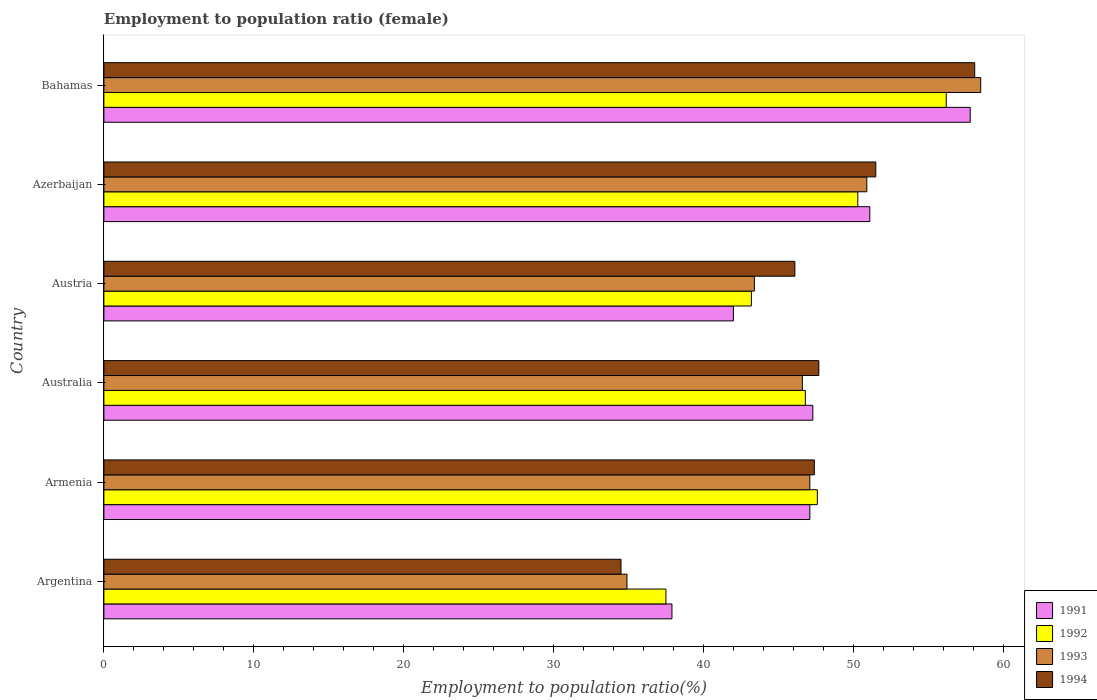How many different coloured bars are there?
Your answer should be very brief. 4. How many groups of bars are there?
Give a very brief answer. 6. Are the number of bars per tick equal to the number of legend labels?
Provide a short and direct response. Yes. Are the number of bars on each tick of the Y-axis equal?
Your response must be concise. Yes. How many bars are there on the 6th tick from the bottom?
Your answer should be very brief. 4. In how many cases, is the number of bars for a given country not equal to the number of legend labels?
Offer a very short reply. 0. What is the employment to population ratio in 1992 in Australia?
Your answer should be very brief. 46.8. Across all countries, what is the maximum employment to population ratio in 1991?
Your answer should be compact. 57.8. Across all countries, what is the minimum employment to population ratio in 1991?
Your answer should be very brief. 37.9. In which country was the employment to population ratio in 1993 maximum?
Your answer should be compact. Bahamas. In which country was the employment to population ratio in 1993 minimum?
Offer a very short reply. Argentina. What is the total employment to population ratio in 1994 in the graph?
Offer a very short reply. 285.3. What is the difference between the employment to population ratio in 1994 in Argentina and that in Armenia?
Make the answer very short. -12.9. What is the difference between the employment to population ratio in 1994 in Argentina and the employment to population ratio in 1993 in Armenia?
Offer a very short reply. -12.6. What is the average employment to population ratio in 1991 per country?
Make the answer very short. 47.2. What is the difference between the employment to population ratio in 1993 and employment to population ratio in 1991 in Austria?
Make the answer very short. 1.4. In how many countries, is the employment to population ratio in 1991 greater than 50 %?
Provide a succinct answer. 2. What is the ratio of the employment to population ratio in 1994 in Argentina to that in Azerbaijan?
Provide a succinct answer. 0.67. Is the employment to population ratio in 1991 in Argentina less than that in Bahamas?
Your answer should be very brief. Yes. Is the difference between the employment to population ratio in 1993 in Australia and Azerbaijan greater than the difference between the employment to population ratio in 1991 in Australia and Azerbaijan?
Your answer should be very brief. No. What is the difference between the highest and the second highest employment to population ratio in 1991?
Make the answer very short. 6.7. What is the difference between the highest and the lowest employment to population ratio in 1994?
Your response must be concise. 23.6. In how many countries, is the employment to population ratio in 1991 greater than the average employment to population ratio in 1991 taken over all countries?
Keep it short and to the point. 3. Is the sum of the employment to population ratio in 1993 in Azerbaijan and Bahamas greater than the maximum employment to population ratio in 1991 across all countries?
Offer a very short reply. Yes. Is it the case that in every country, the sum of the employment to population ratio in 1991 and employment to population ratio in 1993 is greater than the sum of employment to population ratio in 1994 and employment to population ratio in 1992?
Make the answer very short. No. Is it the case that in every country, the sum of the employment to population ratio in 1992 and employment to population ratio in 1991 is greater than the employment to population ratio in 1993?
Give a very brief answer. Yes. Are all the bars in the graph horizontal?
Offer a terse response. Yes. What is the difference between two consecutive major ticks on the X-axis?
Ensure brevity in your answer.  10. Does the graph contain any zero values?
Offer a terse response. No. Does the graph contain grids?
Make the answer very short. No. What is the title of the graph?
Offer a terse response. Employment to population ratio (female). What is the label or title of the Y-axis?
Keep it short and to the point. Country. What is the Employment to population ratio(%) in 1991 in Argentina?
Make the answer very short. 37.9. What is the Employment to population ratio(%) of 1992 in Argentina?
Your answer should be compact. 37.5. What is the Employment to population ratio(%) of 1993 in Argentina?
Make the answer very short. 34.9. What is the Employment to population ratio(%) in 1994 in Argentina?
Provide a short and direct response. 34.5. What is the Employment to population ratio(%) of 1991 in Armenia?
Your response must be concise. 47.1. What is the Employment to population ratio(%) of 1992 in Armenia?
Your answer should be very brief. 47.6. What is the Employment to population ratio(%) of 1993 in Armenia?
Offer a terse response. 47.1. What is the Employment to population ratio(%) in 1994 in Armenia?
Make the answer very short. 47.4. What is the Employment to population ratio(%) in 1991 in Australia?
Ensure brevity in your answer.  47.3. What is the Employment to population ratio(%) in 1992 in Australia?
Make the answer very short. 46.8. What is the Employment to population ratio(%) of 1993 in Australia?
Your answer should be very brief. 46.6. What is the Employment to population ratio(%) of 1994 in Australia?
Your answer should be compact. 47.7. What is the Employment to population ratio(%) of 1992 in Austria?
Your answer should be very brief. 43.2. What is the Employment to population ratio(%) of 1993 in Austria?
Your answer should be compact. 43.4. What is the Employment to population ratio(%) of 1994 in Austria?
Keep it short and to the point. 46.1. What is the Employment to population ratio(%) in 1991 in Azerbaijan?
Provide a succinct answer. 51.1. What is the Employment to population ratio(%) of 1992 in Azerbaijan?
Give a very brief answer. 50.3. What is the Employment to population ratio(%) in 1993 in Azerbaijan?
Ensure brevity in your answer.  50.9. What is the Employment to population ratio(%) in 1994 in Azerbaijan?
Make the answer very short. 51.5. What is the Employment to population ratio(%) in 1991 in Bahamas?
Offer a terse response. 57.8. What is the Employment to population ratio(%) in 1992 in Bahamas?
Your answer should be compact. 56.2. What is the Employment to population ratio(%) in 1993 in Bahamas?
Give a very brief answer. 58.5. What is the Employment to population ratio(%) in 1994 in Bahamas?
Your answer should be very brief. 58.1. Across all countries, what is the maximum Employment to population ratio(%) in 1991?
Your answer should be very brief. 57.8. Across all countries, what is the maximum Employment to population ratio(%) in 1992?
Provide a short and direct response. 56.2. Across all countries, what is the maximum Employment to population ratio(%) in 1993?
Provide a short and direct response. 58.5. Across all countries, what is the maximum Employment to population ratio(%) of 1994?
Give a very brief answer. 58.1. Across all countries, what is the minimum Employment to population ratio(%) in 1991?
Offer a terse response. 37.9. Across all countries, what is the minimum Employment to population ratio(%) in 1992?
Provide a succinct answer. 37.5. Across all countries, what is the minimum Employment to population ratio(%) of 1993?
Provide a short and direct response. 34.9. Across all countries, what is the minimum Employment to population ratio(%) in 1994?
Offer a terse response. 34.5. What is the total Employment to population ratio(%) of 1991 in the graph?
Keep it short and to the point. 283.2. What is the total Employment to population ratio(%) in 1992 in the graph?
Keep it short and to the point. 281.6. What is the total Employment to population ratio(%) of 1993 in the graph?
Give a very brief answer. 281.4. What is the total Employment to population ratio(%) of 1994 in the graph?
Your answer should be very brief. 285.3. What is the difference between the Employment to population ratio(%) in 1991 in Argentina and that in Armenia?
Your answer should be very brief. -9.2. What is the difference between the Employment to population ratio(%) in 1992 in Argentina and that in Armenia?
Make the answer very short. -10.1. What is the difference between the Employment to population ratio(%) of 1993 in Argentina and that in Armenia?
Your answer should be compact. -12.2. What is the difference between the Employment to population ratio(%) of 1991 in Argentina and that in Austria?
Provide a short and direct response. -4.1. What is the difference between the Employment to population ratio(%) of 1992 in Argentina and that in Austria?
Your answer should be very brief. -5.7. What is the difference between the Employment to population ratio(%) of 1994 in Argentina and that in Austria?
Provide a succinct answer. -11.6. What is the difference between the Employment to population ratio(%) of 1991 in Argentina and that in Azerbaijan?
Ensure brevity in your answer.  -13.2. What is the difference between the Employment to population ratio(%) in 1993 in Argentina and that in Azerbaijan?
Give a very brief answer. -16. What is the difference between the Employment to population ratio(%) of 1991 in Argentina and that in Bahamas?
Provide a succinct answer. -19.9. What is the difference between the Employment to population ratio(%) in 1992 in Argentina and that in Bahamas?
Offer a very short reply. -18.7. What is the difference between the Employment to population ratio(%) of 1993 in Argentina and that in Bahamas?
Provide a succinct answer. -23.6. What is the difference between the Employment to population ratio(%) of 1994 in Argentina and that in Bahamas?
Ensure brevity in your answer.  -23.6. What is the difference between the Employment to population ratio(%) in 1993 in Armenia and that in Australia?
Your answer should be very brief. 0.5. What is the difference between the Employment to population ratio(%) of 1994 in Armenia and that in Australia?
Your answer should be compact. -0.3. What is the difference between the Employment to population ratio(%) of 1992 in Armenia and that in Austria?
Provide a short and direct response. 4.4. What is the difference between the Employment to population ratio(%) in 1993 in Armenia and that in Austria?
Give a very brief answer. 3.7. What is the difference between the Employment to population ratio(%) of 1992 in Armenia and that in Azerbaijan?
Offer a very short reply. -2.7. What is the difference between the Employment to population ratio(%) of 1993 in Armenia and that in Azerbaijan?
Provide a short and direct response. -3.8. What is the difference between the Employment to population ratio(%) of 1991 in Armenia and that in Bahamas?
Your answer should be very brief. -10.7. What is the difference between the Employment to population ratio(%) of 1993 in Armenia and that in Bahamas?
Offer a very short reply. -11.4. What is the difference between the Employment to population ratio(%) in 1991 in Australia and that in Austria?
Give a very brief answer. 5.3. What is the difference between the Employment to population ratio(%) of 1992 in Australia and that in Austria?
Provide a succinct answer. 3.6. What is the difference between the Employment to population ratio(%) of 1993 in Australia and that in Austria?
Provide a succinct answer. 3.2. What is the difference between the Employment to population ratio(%) of 1992 in Australia and that in Azerbaijan?
Offer a terse response. -3.5. What is the difference between the Employment to population ratio(%) of 1994 in Australia and that in Azerbaijan?
Provide a short and direct response. -3.8. What is the difference between the Employment to population ratio(%) of 1993 in Australia and that in Bahamas?
Provide a succinct answer. -11.9. What is the difference between the Employment to population ratio(%) in 1991 in Austria and that in Azerbaijan?
Ensure brevity in your answer.  -9.1. What is the difference between the Employment to population ratio(%) of 1992 in Austria and that in Azerbaijan?
Provide a short and direct response. -7.1. What is the difference between the Employment to population ratio(%) in 1991 in Austria and that in Bahamas?
Provide a succinct answer. -15.8. What is the difference between the Employment to population ratio(%) of 1993 in Austria and that in Bahamas?
Give a very brief answer. -15.1. What is the difference between the Employment to population ratio(%) in 1993 in Azerbaijan and that in Bahamas?
Your answer should be compact. -7.6. What is the difference between the Employment to population ratio(%) in 1991 in Argentina and the Employment to population ratio(%) in 1992 in Armenia?
Give a very brief answer. -9.7. What is the difference between the Employment to population ratio(%) in 1991 in Argentina and the Employment to population ratio(%) in 1992 in Australia?
Provide a short and direct response. -8.9. What is the difference between the Employment to population ratio(%) of 1991 in Argentina and the Employment to population ratio(%) of 1994 in Australia?
Your answer should be very brief. -9.8. What is the difference between the Employment to population ratio(%) of 1993 in Argentina and the Employment to population ratio(%) of 1994 in Australia?
Make the answer very short. -12.8. What is the difference between the Employment to population ratio(%) of 1991 in Argentina and the Employment to population ratio(%) of 1992 in Austria?
Your answer should be very brief. -5.3. What is the difference between the Employment to population ratio(%) in 1991 in Argentina and the Employment to population ratio(%) in 1993 in Austria?
Your answer should be very brief. -5.5. What is the difference between the Employment to population ratio(%) of 1991 in Argentina and the Employment to population ratio(%) of 1994 in Austria?
Offer a terse response. -8.2. What is the difference between the Employment to population ratio(%) of 1992 in Argentina and the Employment to population ratio(%) of 1994 in Austria?
Ensure brevity in your answer.  -8.6. What is the difference between the Employment to population ratio(%) of 1992 in Argentina and the Employment to population ratio(%) of 1994 in Azerbaijan?
Provide a short and direct response. -14. What is the difference between the Employment to population ratio(%) of 1993 in Argentina and the Employment to population ratio(%) of 1994 in Azerbaijan?
Keep it short and to the point. -16.6. What is the difference between the Employment to population ratio(%) of 1991 in Argentina and the Employment to population ratio(%) of 1992 in Bahamas?
Provide a short and direct response. -18.3. What is the difference between the Employment to population ratio(%) in 1991 in Argentina and the Employment to population ratio(%) in 1993 in Bahamas?
Your answer should be very brief. -20.6. What is the difference between the Employment to population ratio(%) in 1991 in Argentina and the Employment to population ratio(%) in 1994 in Bahamas?
Keep it short and to the point. -20.2. What is the difference between the Employment to population ratio(%) of 1992 in Argentina and the Employment to population ratio(%) of 1993 in Bahamas?
Ensure brevity in your answer.  -21. What is the difference between the Employment to population ratio(%) of 1992 in Argentina and the Employment to population ratio(%) of 1994 in Bahamas?
Your answer should be very brief. -20.6. What is the difference between the Employment to population ratio(%) of 1993 in Argentina and the Employment to population ratio(%) of 1994 in Bahamas?
Give a very brief answer. -23.2. What is the difference between the Employment to population ratio(%) in 1992 in Armenia and the Employment to population ratio(%) in 1993 in Australia?
Offer a terse response. 1. What is the difference between the Employment to population ratio(%) of 1992 in Armenia and the Employment to population ratio(%) of 1994 in Australia?
Give a very brief answer. -0.1. What is the difference between the Employment to population ratio(%) of 1991 in Armenia and the Employment to population ratio(%) of 1992 in Austria?
Keep it short and to the point. 3.9. What is the difference between the Employment to population ratio(%) of 1991 in Armenia and the Employment to population ratio(%) of 1993 in Austria?
Offer a very short reply. 3.7. What is the difference between the Employment to population ratio(%) in 1991 in Armenia and the Employment to population ratio(%) in 1992 in Azerbaijan?
Provide a succinct answer. -3.2. What is the difference between the Employment to population ratio(%) in 1991 in Armenia and the Employment to population ratio(%) in 1993 in Azerbaijan?
Your response must be concise. -3.8. What is the difference between the Employment to population ratio(%) in 1991 in Armenia and the Employment to population ratio(%) in 1994 in Azerbaijan?
Your answer should be compact. -4.4. What is the difference between the Employment to population ratio(%) in 1993 in Armenia and the Employment to population ratio(%) in 1994 in Azerbaijan?
Offer a very short reply. -4.4. What is the difference between the Employment to population ratio(%) of 1991 in Armenia and the Employment to population ratio(%) of 1994 in Bahamas?
Make the answer very short. -11. What is the difference between the Employment to population ratio(%) in 1992 in Armenia and the Employment to population ratio(%) in 1994 in Bahamas?
Make the answer very short. -10.5. What is the difference between the Employment to population ratio(%) in 1991 in Australia and the Employment to population ratio(%) in 1993 in Austria?
Provide a succinct answer. 3.9. What is the difference between the Employment to population ratio(%) in 1993 in Australia and the Employment to population ratio(%) in 1994 in Austria?
Your response must be concise. 0.5. What is the difference between the Employment to population ratio(%) of 1991 in Australia and the Employment to population ratio(%) of 1993 in Azerbaijan?
Your answer should be very brief. -3.6. What is the difference between the Employment to population ratio(%) in 1991 in Australia and the Employment to population ratio(%) in 1994 in Azerbaijan?
Your answer should be very brief. -4.2. What is the difference between the Employment to population ratio(%) of 1992 in Australia and the Employment to population ratio(%) of 1994 in Azerbaijan?
Provide a succinct answer. -4.7. What is the difference between the Employment to population ratio(%) of 1991 in Australia and the Employment to population ratio(%) of 1992 in Bahamas?
Make the answer very short. -8.9. What is the difference between the Employment to population ratio(%) in 1991 in Austria and the Employment to population ratio(%) in 1993 in Azerbaijan?
Your answer should be very brief. -8.9. What is the difference between the Employment to population ratio(%) of 1991 in Austria and the Employment to population ratio(%) of 1994 in Azerbaijan?
Your response must be concise. -9.5. What is the difference between the Employment to population ratio(%) of 1991 in Austria and the Employment to population ratio(%) of 1992 in Bahamas?
Offer a terse response. -14.2. What is the difference between the Employment to population ratio(%) in 1991 in Austria and the Employment to population ratio(%) in 1993 in Bahamas?
Provide a succinct answer. -16.5. What is the difference between the Employment to population ratio(%) in 1991 in Austria and the Employment to population ratio(%) in 1994 in Bahamas?
Give a very brief answer. -16.1. What is the difference between the Employment to population ratio(%) in 1992 in Austria and the Employment to population ratio(%) in 1993 in Bahamas?
Give a very brief answer. -15.3. What is the difference between the Employment to population ratio(%) of 1992 in Austria and the Employment to population ratio(%) of 1994 in Bahamas?
Give a very brief answer. -14.9. What is the difference between the Employment to population ratio(%) in 1993 in Austria and the Employment to population ratio(%) in 1994 in Bahamas?
Make the answer very short. -14.7. What is the difference between the Employment to population ratio(%) in 1991 in Azerbaijan and the Employment to population ratio(%) in 1994 in Bahamas?
Your response must be concise. -7. What is the difference between the Employment to population ratio(%) in 1992 in Azerbaijan and the Employment to population ratio(%) in 1993 in Bahamas?
Offer a terse response. -8.2. What is the difference between the Employment to population ratio(%) in 1992 in Azerbaijan and the Employment to population ratio(%) in 1994 in Bahamas?
Provide a short and direct response. -7.8. What is the difference between the Employment to population ratio(%) of 1993 in Azerbaijan and the Employment to population ratio(%) of 1994 in Bahamas?
Offer a terse response. -7.2. What is the average Employment to population ratio(%) in 1991 per country?
Give a very brief answer. 47.2. What is the average Employment to population ratio(%) of 1992 per country?
Give a very brief answer. 46.93. What is the average Employment to population ratio(%) of 1993 per country?
Provide a succinct answer. 46.9. What is the average Employment to population ratio(%) of 1994 per country?
Offer a terse response. 47.55. What is the difference between the Employment to population ratio(%) of 1991 and Employment to population ratio(%) of 1992 in Argentina?
Keep it short and to the point. 0.4. What is the difference between the Employment to population ratio(%) of 1991 and Employment to population ratio(%) of 1993 in Argentina?
Keep it short and to the point. 3. What is the difference between the Employment to population ratio(%) in 1992 and Employment to population ratio(%) in 1994 in Argentina?
Give a very brief answer. 3. What is the difference between the Employment to population ratio(%) in 1993 and Employment to population ratio(%) in 1994 in Argentina?
Provide a short and direct response. 0.4. What is the difference between the Employment to population ratio(%) of 1993 and Employment to population ratio(%) of 1994 in Armenia?
Your response must be concise. -0.3. What is the difference between the Employment to population ratio(%) in 1991 and Employment to population ratio(%) in 1994 in Australia?
Your response must be concise. -0.4. What is the difference between the Employment to population ratio(%) in 1992 and Employment to population ratio(%) in 1993 in Australia?
Keep it short and to the point. 0.2. What is the difference between the Employment to population ratio(%) of 1991 and Employment to population ratio(%) of 1993 in Austria?
Ensure brevity in your answer.  -1.4. What is the difference between the Employment to population ratio(%) of 1991 and Employment to population ratio(%) of 1994 in Austria?
Provide a succinct answer. -4.1. What is the difference between the Employment to population ratio(%) in 1992 and Employment to population ratio(%) in 1993 in Austria?
Offer a terse response. -0.2. What is the difference between the Employment to population ratio(%) of 1992 and Employment to population ratio(%) of 1994 in Austria?
Provide a short and direct response. -2.9. What is the difference between the Employment to population ratio(%) in 1991 and Employment to population ratio(%) in 1993 in Azerbaijan?
Your answer should be very brief. 0.2. What is the difference between the Employment to population ratio(%) in 1992 and Employment to population ratio(%) in 1994 in Azerbaijan?
Your answer should be compact. -1.2. What is the difference between the Employment to population ratio(%) in 1993 and Employment to population ratio(%) in 1994 in Azerbaijan?
Provide a succinct answer. -0.6. What is the difference between the Employment to population ratio(%) in 1991 and Employment to population ratio(%) in 1992 in Bahamas?
Provide a short and direct response. 1.6. What is the difference between the Employment to population ratio(%) of 1991 and Employment to population ratio(%) of 1994 in Bahamas?
Ensure brevity in your answer.  -0.3. What is the difference between the Employment to population ratio(%) of 1992 and Employment to population ratio(%) of 1994 in Bahamas?
Offer a very short reply. -1.9. What is the difference between the Employment to population ratio(%) in 1993 and Employment to population ratio(%) in 1994 in Bahamas?
Offer a very short reply. 0.4. What is the ratio of the Employment to population ratio(%) in 1991 in Argentina to that in Armenia?
Make the answer very short. 0.8. What is the ratio of the Employment to population ratio(%) in 1992 in Argentina to that in Armenia?
Offer a very short reply. 0.79. What is the ratio of the Employment to population ratio(%) of 1993 in Argentina to that in Armenia?
Offer a terse response. 0.74. What is the ratio of the Employment to population ratio(%) in 1994 in Argentina to that in Armenia?
Your answer should be compact. 0.73. What is the ratio of the Employment to population ratio(%) of 1991 in Argentina to that in Australia?
Your answer should be very brief. 0.8. What is the ratio of the Employment to population ratio(%) in 1992 in Argentina to that in Australia?
Your answer should be very brief. 0.8. What is the ratio of the Employment to population ratio(%) of 1993 in Argentina to that in Australia?
Keep it short and to the point. 0.75. What is the ratio of the Employment to population ratio(%) of 1994 in Argentina to that in Australia?
Your answer should be compact. 0.72. What is the ratio of the Employment to population ratio(%) in 1991 in Argentina to that in Austria?
Provide a succinct answer. 0.9. What is the ratio of the Employment to population ratio(%) of 1992 in Argentina to that in Austria?
Your response must be concise. 0.87. What is the ratio of the Employment to population ratio(%) in 1993 in Argentina to that in Austria?
Offer a terse response. 0.8. What is the ratio of the Employment to population ratio(%) in 1994 in Argentina to that in Austria?
Provide a succinct answer. 0.75. What is the ratio of the Employment to population ratio(%) of 1991 in Argentina to that in Azerbaijan?
Ensure brevity in your answer.  0.74. What is the ratio of the Employment to population ratio(%) of 1992 in Argentina to that in Azerbaijan?
Offer a very short reply. 0.75. What is the ratio of the Employment to population ratio(%) in 1993 in Argentina to that in Azerbaijan?
Your response must be concise. 0.69. What is the ratio of the Employment to population ratio(%) of 1994 in Argentina to that in Azerbaijan?
Your response must be concise. 0.67. What is the ratio of the Employment to population ratio(%) in 1991 in Argentina to that in Bahamas?
Give a very brief answer. 0.66. What is the ratio of the Employment to population ratio(%) in 1992 in Argentina to that in Bahamas?
Provide a short and direct response. 0.67. What is the ratio of the Employment to population ratio(%) in 1993 in Argentina to that in Bahamas?
Offer a terse response. 0.6. What is the ratio of the Employment to population ratio(%) in 1994 in Argentina to that in Bahamas?
Give a very brief answer. 0.59. What is the ratio of the Employment to population ratio(%) of 1991 in Armenia to that in Australia?
Provide a short and direct response. 1. What is the ratio of the Employment to population ratio(%) of 1992 in Armenia to that in Australia?
Give a very brief answer. 1.02. What is the ratio of the Employment to population ratio(%) in 1993 in Armenia to that in Australia?
Give a very brief answer. 1.01. What is the ratio of the Employment to population ratio(%) of 1991 in Armenia to that in Austria?
Give a very brief answer. 1.12. What is the ratio of the Employment to population ratio(%) of 1992 in Armenia to that in Austria?
Your answer should be very brief. 1.1. What is the ratio of the Employment to population ratio(%) in 1993 in Armenia to that in Austria?
Your answer should be very brief. 1.09. What is the ratio of the Employment to population ratio(%) of 1994 in Armenia to that in Austria?
Offer a terse response. 1.03. What is the ratio of the Employment to population ratio(%) in 1991 in Armenia to that in Azerbaijan?
Make the answer very short. 0.92. What is the ratio of the Employment to population ratio(%) of 1992 in Armenia to that in Azerbaijan?
Your answer should be very brief. 0.95. What is the ratio of the Employment to population ratio(%) in 1993 in Armenia to that in Azerbaijan?
Provide a succinct answer. 0.93. What is the ratio of the Employment to population ratio(%) in 1994 in Armenia to that in Azerbaijan?
Your answer should be compact. 0.92. What is the ratio of the Employment to population ratio(%) of 1991 in Armenia to that in Bahamas?
Provide a short and direct response. 0.81. What is the ratio of the Employment to population ratio(%) of 1992 in Armenia to that in Bahamas?
Ensure brevity in your answer.  0.85. What is the ratio of the Employment to population ratio(%) of 1993 in Armenia to that in Bahamas?
Your answer should be compact. 0.81. What is the ratio of the Employment to population ratio(%) of 1994 in Armenia to that in Bahamas?
Your response must be concise. 0.82. What is the ratio of the Employment to population ratio(%) of 1991 in Australia to that in Austria?
Your answer should be compact. 1.13. What is the ratio of the Employment to population ratio(%) in 1992 in Australia to that in Austria?
Offer a terse response. 1.08. What is the ratio of the Employment to population ratio(%) in 1993 in Australia to that in Austria?
Your answer should be very brief. 1.07. What is the ratio of the Employment to population ratio(%) of 1994 in Australia to that in Austria?
Offer a terse response. 1.03. What is the ratio of the Employment to population ratio(%) in 1991 in Australia to that in Azerbaijan?
Offer a very short reply. 0.93. What is the ratio of the Employment to population ratio(%) in 1992 in Australia to that in Azerbaijan?
Make the answer very short. 0.93. What is the ratio of the Employment to population ratio(%) of 1993 in Australia to that in Azerbaijan?
Provide a short and direct response. 0.92. What is the ratio of the Employment to population ratio(%) of 1994 in Australia to that in Azerbaijan?
Your answer should be very brief. 0.93. What is the ratio of the Employment to population ratio(%) in 1991 in Australia to that in Bahamas?
Offer a very short reply. 0.82. What is the ratio of the Employment to population ratio(%) of 1992 in Australia to that in Bahamas?
Provide a short and direct response. 0.83. What is the ratio of the Employment to population ratio(%) of 1993 in Australia to that in Bahamas?
Offer a terse response. 0.8. What is the ratio of the Employment to population ratio(%) of 1994 in Australia to that in Bahamas?
Provide a succinct answer. 0.82. What is the ratio of the Employment to population ratio(%) in 1991 in Austria to that in Azerbaijan?
Ensure brevity in your answer.  0.82. What is the ratio of the Employment to population ratio(%) of 1992 in Austria to that in Azerbaijan?
Your answer should be very brief. 0.86. What is the ratio of the Employment to population ratio(%) in 1993 in Austria to that in Azerbaijan?
Ensure brevity in your answer.  0.85. What is the ratio of the Employment to population ratio(%) in 1994 in Austria to that in Azerbaijan?
Your answer should be compact. 0.9. What is the ratio of the Employment to population ratio(%) in 1991 in Austria to that in Bahamas?
Provide a short and direct response. 0.73. What is the ratio of the Employment to population ratio(%) of 1992 in Austria to that in Bahamas?
Ensure brevity in your answer.  0.77. What is the ratio of the Employment to population ratio(%) of 1993 in Austria to that in Bahamas?
Your answer should be very brief. 0.74. What is the ratio of the Employment to population ratio(%) of 1994 in Austria to that in Bahamas?
Offer a terse response. 0.79. What is the ratio of the Employment to population ratio(%) of 1991 in Azerbaijan to that in Bahamas?
Your response must be concise. 0.88. What is the ratio of the Employment to population ratio(%) of 1992 in Azerbaijan to that in Bahamas?
Make the answer very short. 0.9. What is the ratio of the Employment to population ratio(%) in 1993 in Azerbaijan to that in Bahamas?
Your response must be concise. 0.87. What is the ratio of the Employment to population ratio(%) of 1994 in Azerbaijan to that in Bahamas?
Make the answer very short. 0.89. What is the difference between the highest and the second highest Employment to population ratio(%) in 1991?
Your response must be concise. 6.7. What is the difference between the highest and the second highest Employment to population ratio(%) of 1993?
Your answer should be compact. 7.6. What is the difference between the highest and the lowest Employment to population ratio(%) in 1991?
Keep it short and to the point. 19.9. What is the difference between the highest and the lowest Employment to population ratio(%) of 1992?
Your answer should be compact. 18.7. What is the difference between the highest and the lowest Employment to population ratio(%) in 1993?
Your response must be concise. 23.6. What is the difference between the highest and the lowest Employment to population ratio(%) in 1994?
Provide a succinct answer. 23.6. 